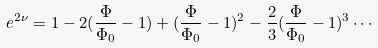<formula> <loc_0><loc_0><loc_500><loc_500>e ^ { 2 \nu } = 1 - 2 ( \frac { \Phi } { \Phi _ { 0 } } - 1 ) + ( \frac { \Phi } { \Phi _ { 0 } } - 1 ) ^ { 2 } - \frac { 2 } { 3 } ( \frac { \Phi } { \Phi _ { 0 } } - 1 ) ^ { 3 } \cdots</formula> 